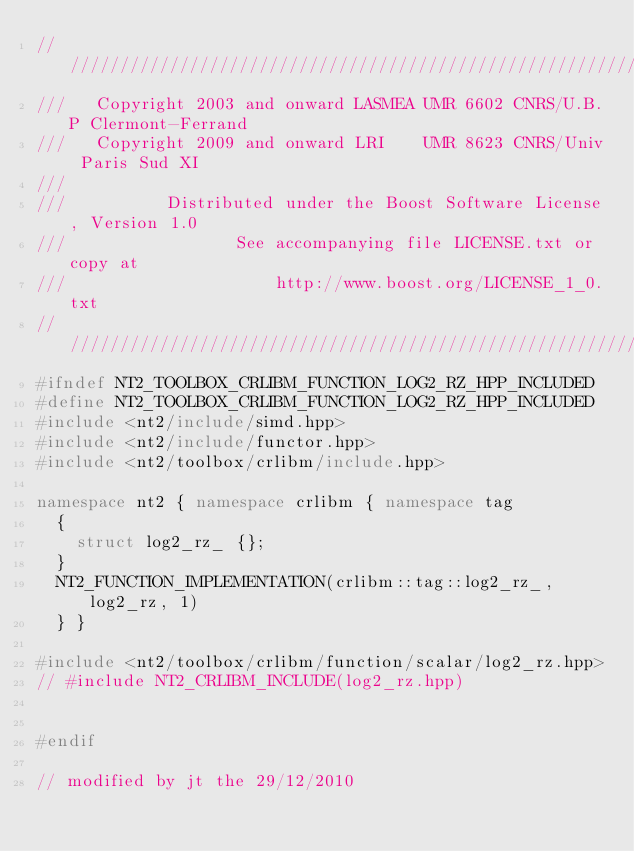Convert code to text. <code><loc_0><loc_0><loc_500><loc_500><_C++_>//////////////////////////////////////////////////////////////////////////////
///   Copyright 2003 and onward LASMEA UMR 6602 CNRS/U.B.P Clermont-Ferrand
///   Copyright 2009 and onward LRI    UMR 8623 CNRS/Univ Paris Sud XI
///
///          Distributed under the Boost Software License, Version 1.0
///                 See accompanying file LICENSE.txt or copy at
///                     http://www.boost.org/LICENSE_1_0.txt
//////////////////////////////////////////////////////////////////////////////
#ifndef NT2_TOOLBOX_CRLIBM_FUNCTION_LOG2_RZ_HPP_INCLUDED
#define NT2_TOOLBOX_CRLIBM_FUNCTION_LOG2_RZ_HPP_INCLUDED
#include <nt2/include/simd.hpp>
#include <nt2/include/functor.hpp>
#include <nt2/toolbox/crlibm/include.hpp>

namespace nt2 { namespace crlibm { namespace tag
  {         
    struct log2_rz_ {};
  }
  NT2_FUNCTION_IMPLEMENTATION(crlibm::tag::log2_rz_, log2_rz, 1)
  } }
 
#include <nt2/toolbox/crlibm/function/scalar/log2_rz.hpp>
// #include NT2_CRLIBM_INCLUDE(log2_rz.hpp) 

 
#endif

// modified by jt the 29/12/2010</code> 